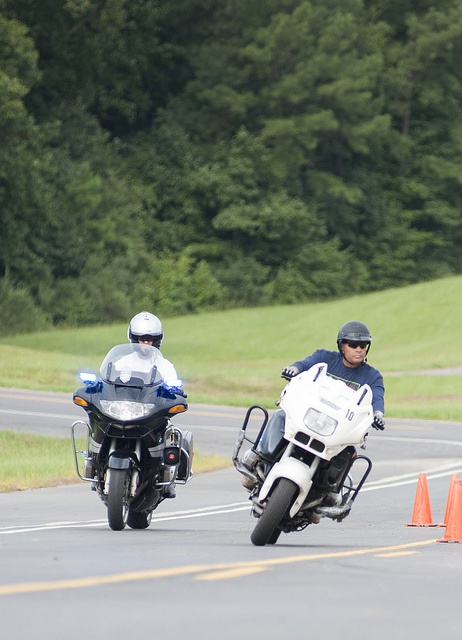Describe the objects in this image and their specific colors. I can see motorcycle in darkgreen, lightgray, black, gray, and darkgray tones, motorcycle in darkgreen, black, lightgray, gray, and darkgray tones, people in darkgreen, gray, darkblue, and darkgray tones, and people in darkgreen, white, darkgray, and black tones in this image. 